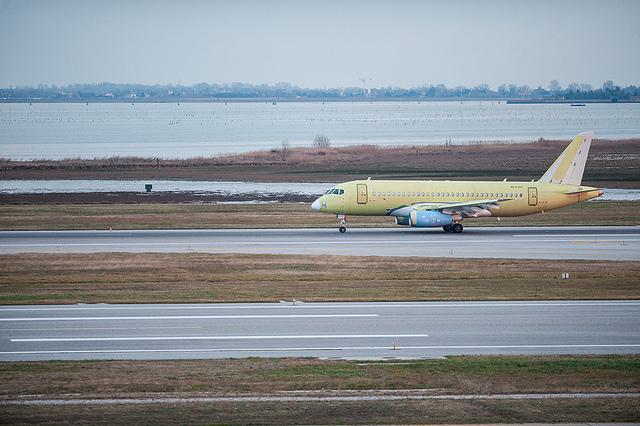How many planes are there?
Short answer required. 1. Is the plane flying?
Short answer required. No. How many engines are visible?
Be succinct. 2. 